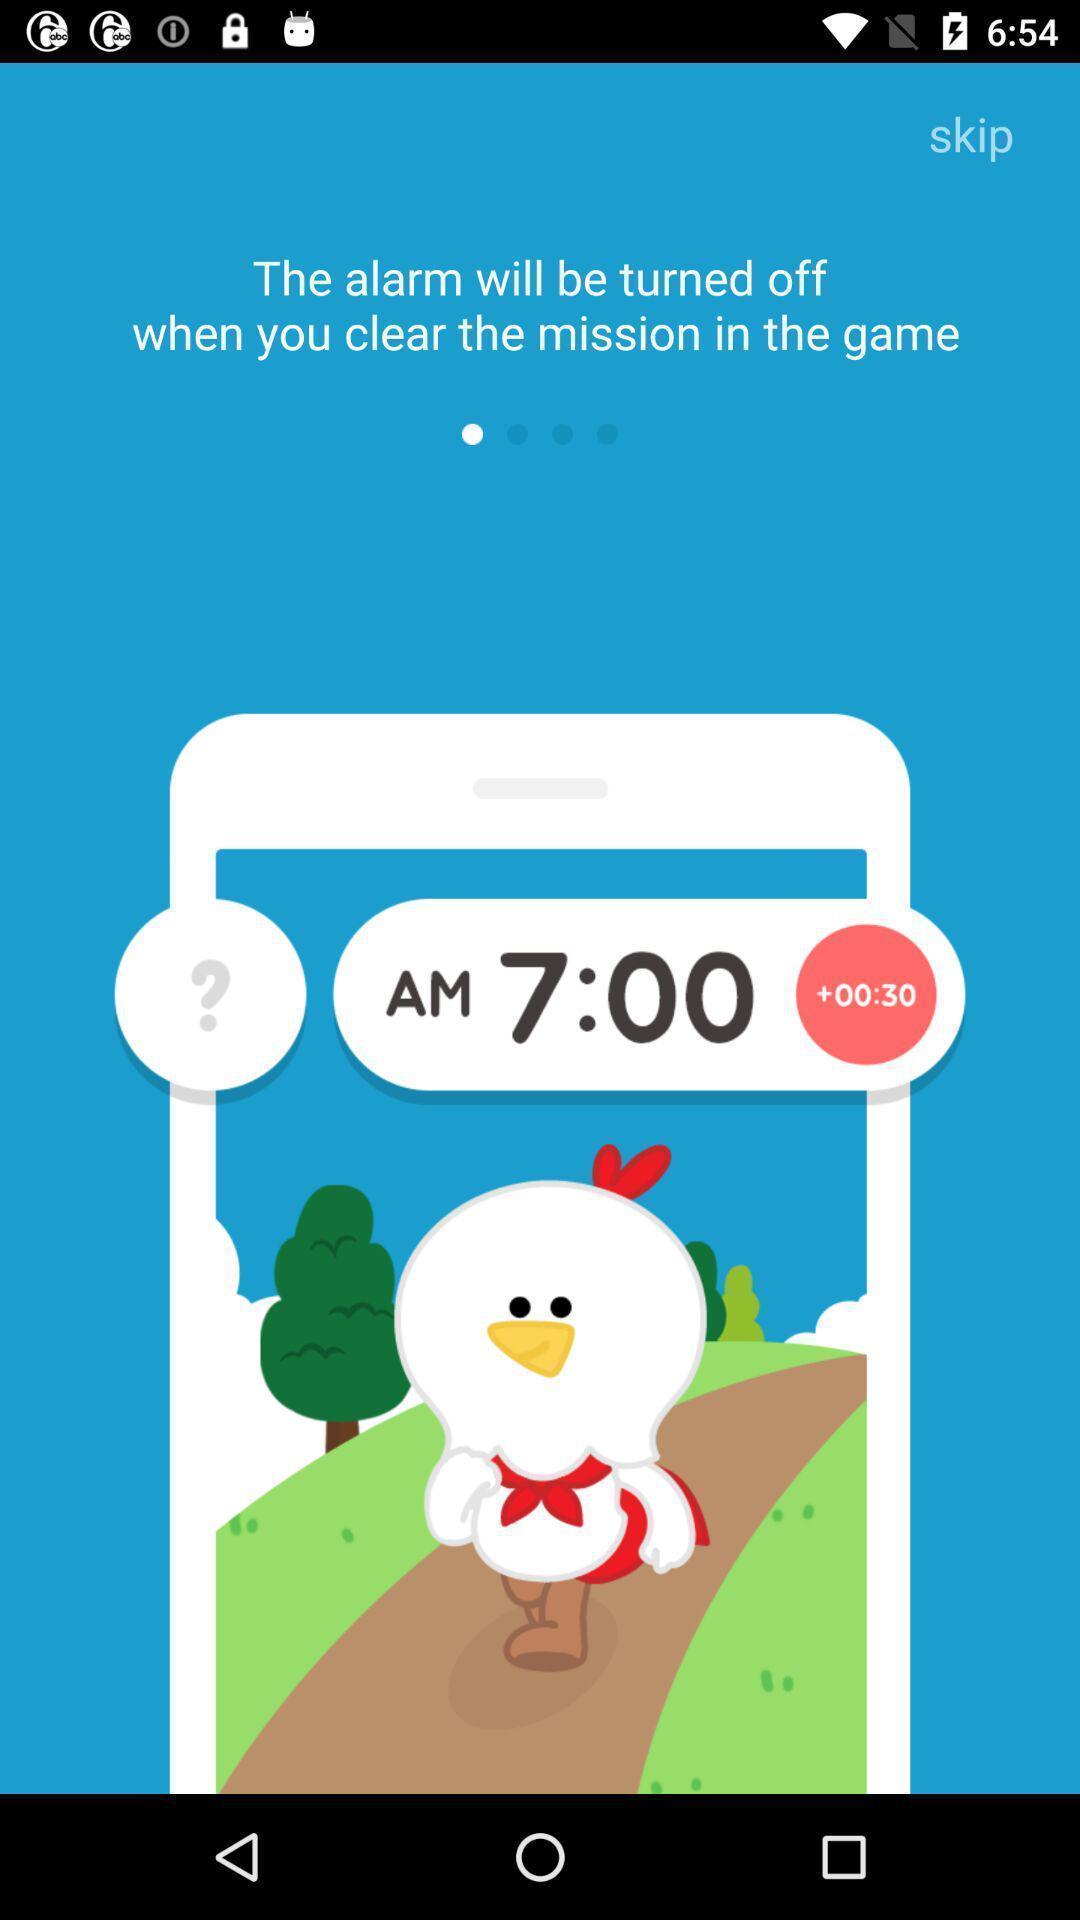What details can you identify in this image? Welcome page. 